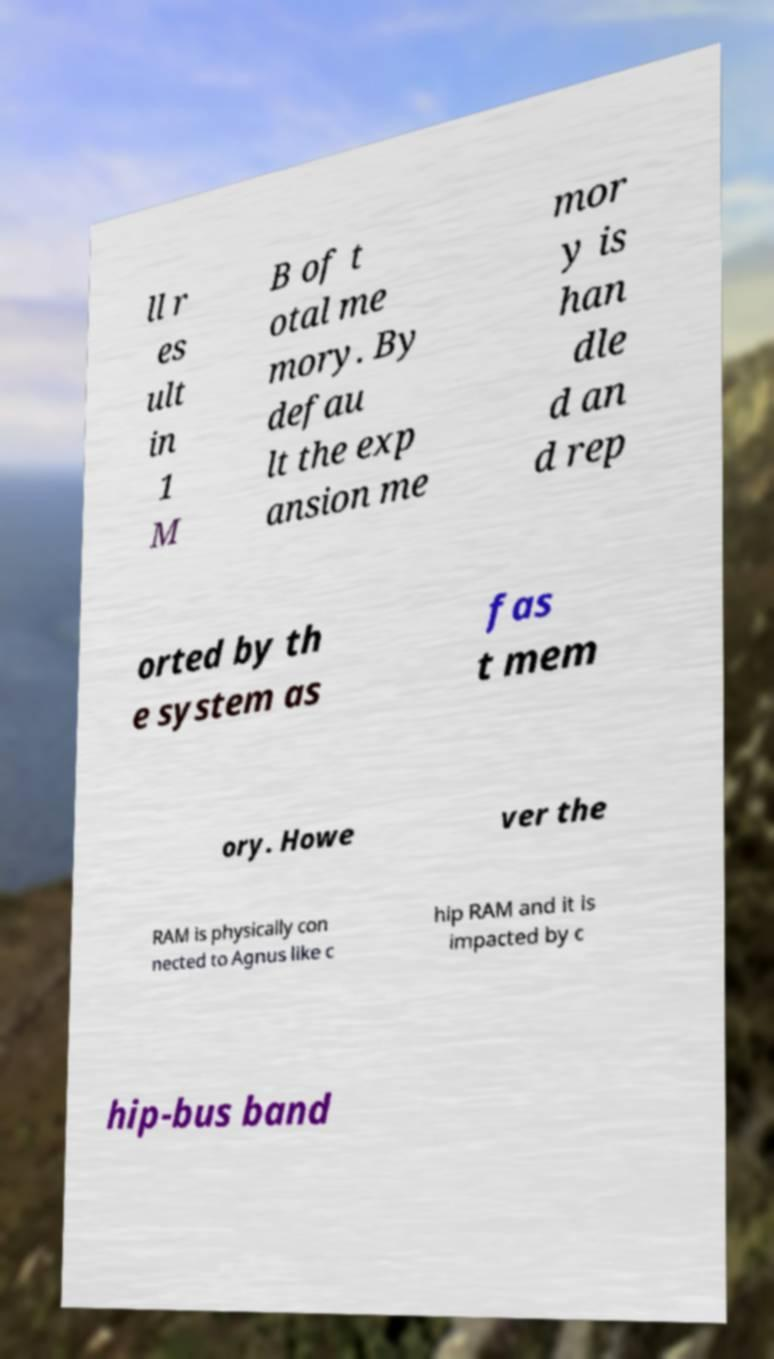For documentation purposes, I need the text within this image transcribed. Could you provide that? ll r es ult in 1 M B of t otal me mory. By defau lt the exp ansion me mor y is han dle d an d rep orted by th e system as fas t mem ory. Howe ver the RAM is physically con nected to Agnus like c hip RAM and it is impacted by c hip-bus band 